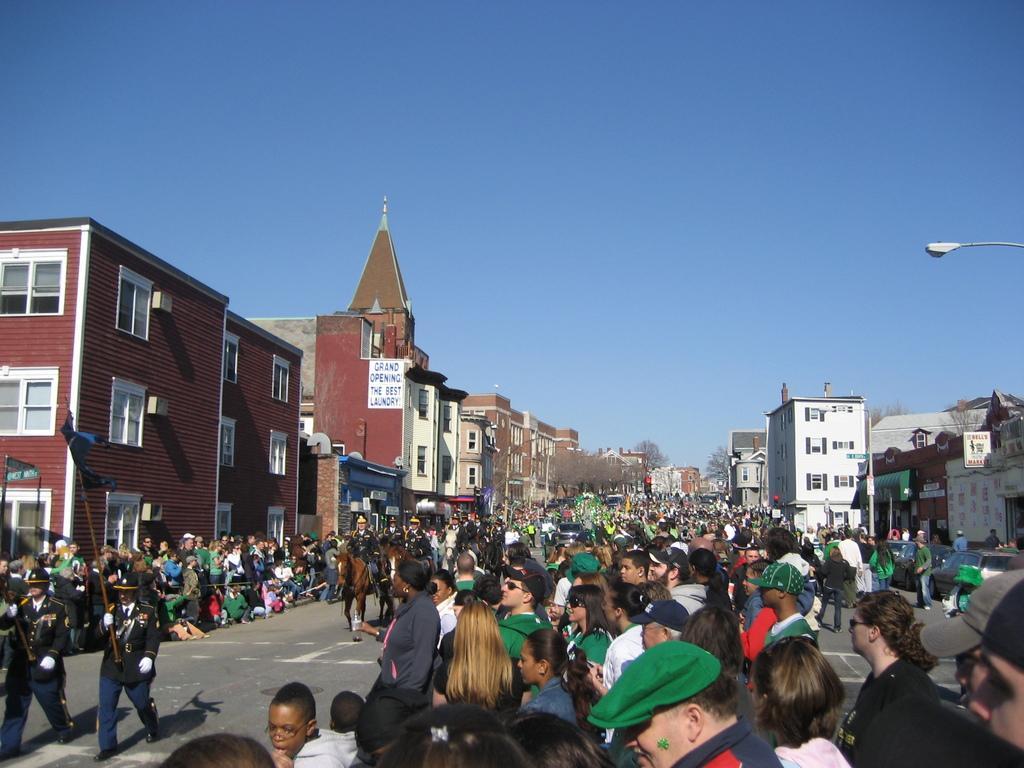Please provide a concise description of this image. In this image, there are a few people and buildings. We can see the ground. There are a few poles, boards with text. We can also see some trees and flags. We can also see the sky. 